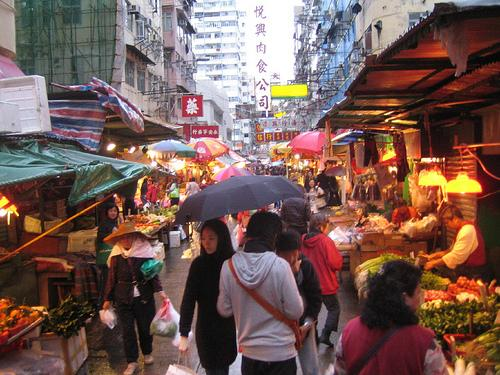What is the occupation of the man in the red vest? Please explain your reasoning. produce vendor. He is behind the lettuce or celery that is on the table. it looks like he is doing something work related behind the counter. 